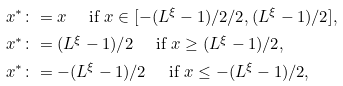<formula> <loc_0><loc_0><loc_500><loc_500>x ^ { * } & \colon = x \quad \text { if } x \in [ - ( L ^ { \xi } - 1 ) / 2 / 2 , ( L ^ { \xi } - 1 ) / 2 ] , \\ x ^ { * } & \colon = ( L ^ { \xi } - 1 ) / 2 \quad \text { if } x \geq ( L ^ { \xi } - 1 ) / 2 , \\ x ^ { * } & \colon = - ( L ^ { \xi } - 1 ) / 2 \quad \text { if } x \leq - ( L ^ { \xi } - 1 ) / 2 ,</formula> 